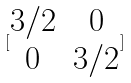<formula> <loc_0><loc_0><loc_500><loc_500>[ \begin{matrix} 3 / 2 & 0 \\ 0 & 3 / 2 \end{matrix} ]</formula> 